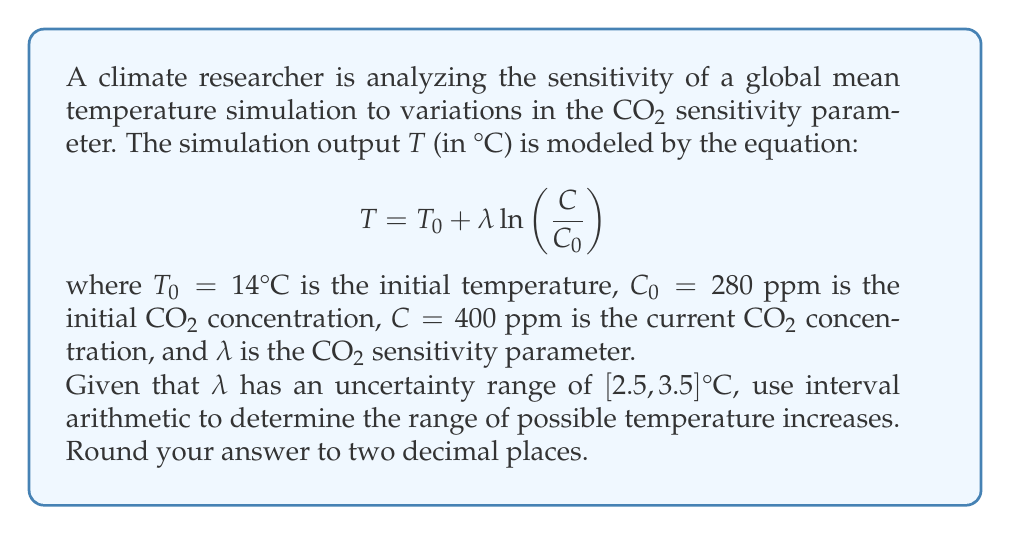Help me with this question. To solve this problem, we'll use interval arithmetic to propagate the uncertainty in $\lambda$ through the equation:

1) First, let's simplify the equation by substituting the known values:
   $$T - T_0 = \lambda \ln\left(\frac{400}{280}\right)$$

2) Calculate $\ln\left(\frac{400}{280}\right)$:
   $$\ln\left(\frac{400}{280}\right) \approx 0.3567$$

3) Now our equation becomes:
   $$T - 14 = \lambda \cdot 0.3567$$

4) Using interval arithmetic, we can represent $\lambda$ as $[2.5, 3.5]$:
   $$T - 14 = [2.5, 3.5] \cdot 0.3567$$

5) Multiply the interval by 0.3567:
   $$T - 14 = [2.5 \cdot 0.3567, 3.5 \cdot 0.3567] = [0.8918, 1.2485]$$

6) Add 14 to both sides:
   $$T = [14 + 0.8918, 14 + 1.2485] = [14.8918, 15.2485]$$

7) The temperature increase is the difference between these values and the initial temperature:
   $$\Delta T = [14.8918 - 14, 15.2485 - 14] = [0.8918, 1.2485]$$

8) Rounding to two decimal places:
   $$\Delta T = [0.89, 1.25]°C$$
Answer: The range of possible temperature increases is $[0.89, 1.25]°C$. 